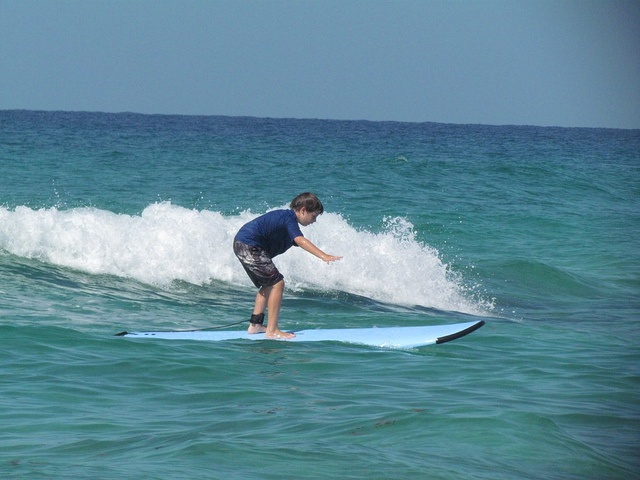Describe the objects in this image and their specific colors. I can see people in gray, black, navy, and tan tones and surfboard in gray, lightblue, and teal tones in this image. 